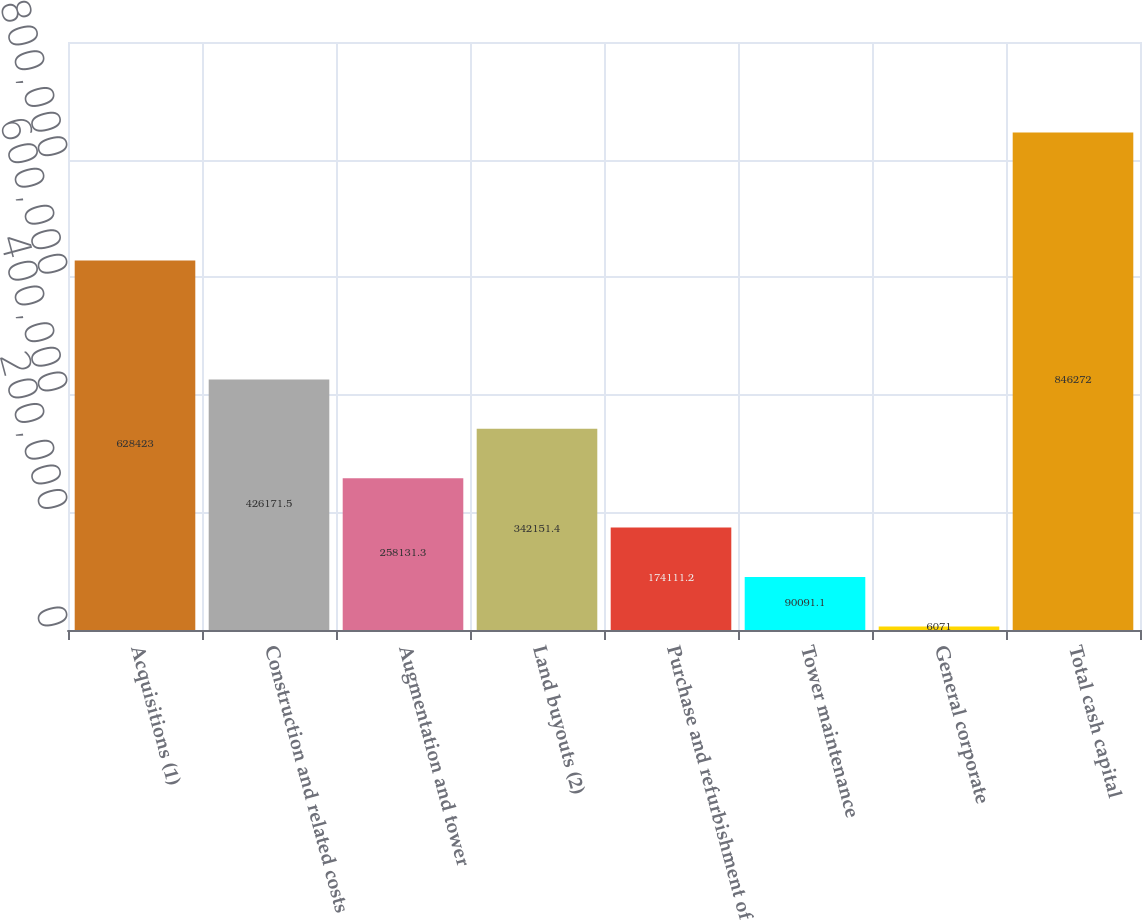Convert chart to OTSL. <chart><loc_0><loc_0><loc_500><loc_500><bar_chart><fcel>Acquisitions (1)<fcel>Construction and related costs<fcel>Augmentation and tower<fcel>Land buyouts (2)<fcel>Purchase and refurbishment of<fcel>Tower maintenance<fcel>General corporate<fcel>Total cash capital<nl><fcel>628423<fcel>426172<fcel>258131<fcel>342151<fcel>174111<fcel>90091.1<fcel>6071<fcel>846272<nl></chart> 